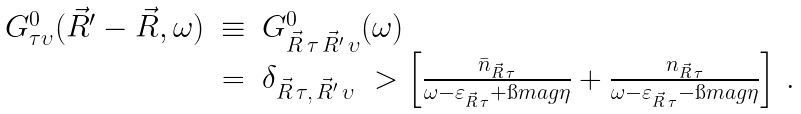Convert formula to latex. <formula><loc_0><loc_0><loc_500><loc_500>\begin{array} { r c l } G ^ { 0 } _ { \tau \upsilon } ( \vec { R } ^ { \prime } - \vec { R } , \omega ) & \equiv & G ^ { 0 } _ { \vec { R } \, \tau \, \vec { R } ^ { \prime } \, \upsilon } ( \omega ) \\ & = & \delta _ { \vec { R } \, \tau , \, \vec { R } ^ { \prime } \, \upsilon } \ > \left [ \frac { \bar { n } _ { \vec { R } \, \tau } } { \omega - \varepsilon _ { \vec { R } \, \tau } + \i m a g \eta } + \frac { n _ { \vec { R } \, \tau } } { \omega - \varepsilon _ { \vec { R } \, \tau } - \i m a g \eta } \right ] \, . \end{array}</formula> 